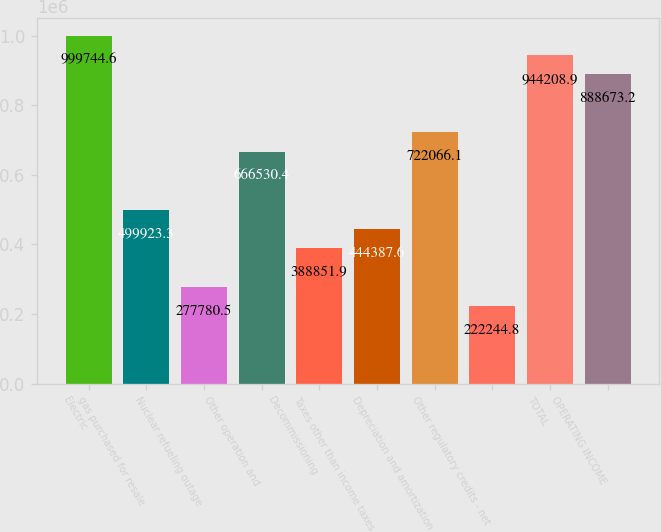Convert chart to OTSL. <chart><loc_0><loc_0><loc_500><loc_500><bar_chart><fcel>Electric<fcel>gas purchased for resale<fcel>Nuclear refueling outage<fcel>Other operation and<fcel>Decommissioning<fcel>Taxes other than income taxes<fcel>Depreciation and amortization<fcel>Other regulatory credits - net<fcel>TOTAL<fcel>OPERATING INCOME<nl><fcel>999745<fcel>499923<fcel>277780<fcel>666530<fcel>388852<fcel>444388<fcel>722066<fcel>222245<fcel>944209<fcel>888673<nl></chart> 